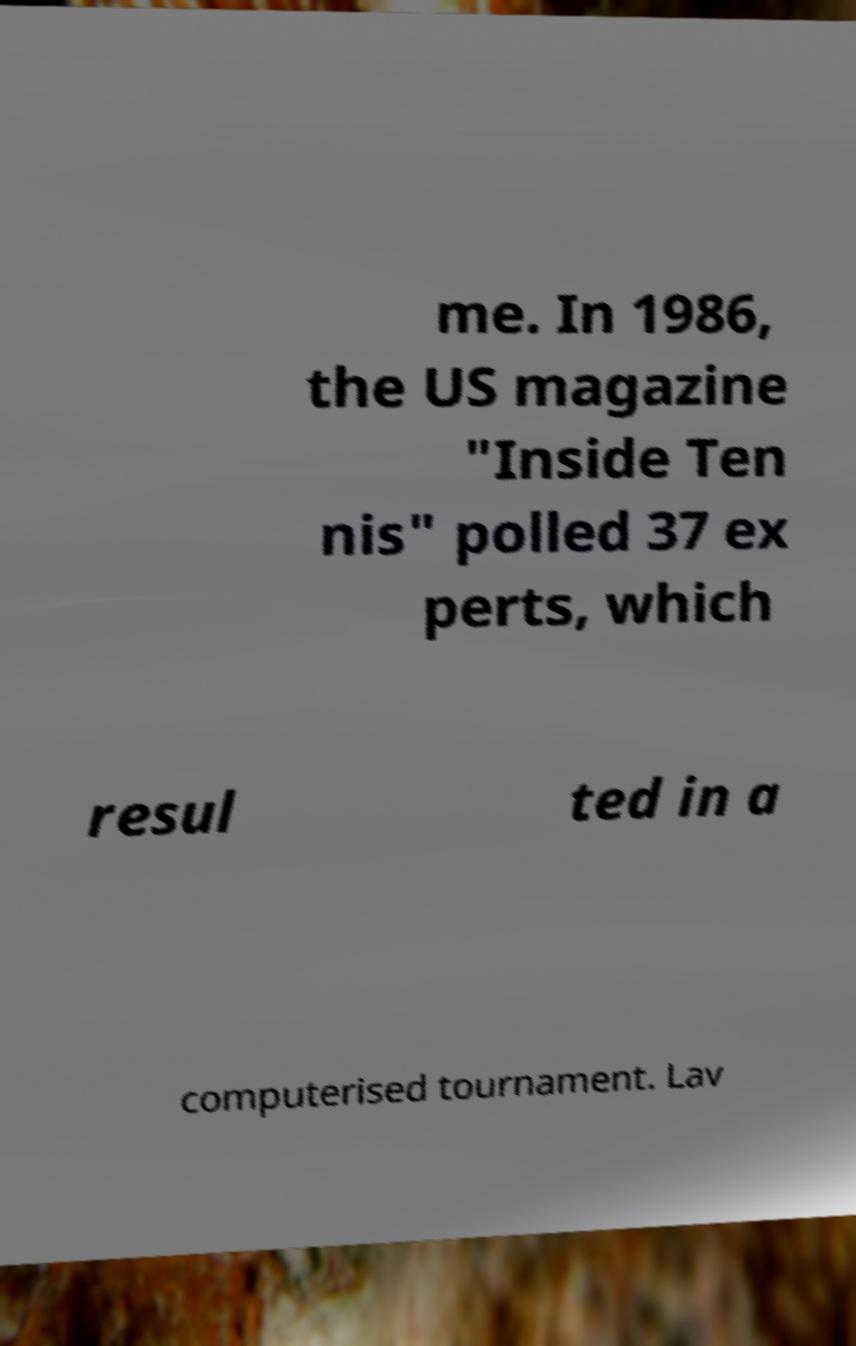Please identify and transcribe the text found in this image. me. In 1986, the US magazine "Inside Ten nis" polled 37 ex perts, which resul ted in a computerised tournament. Lav 